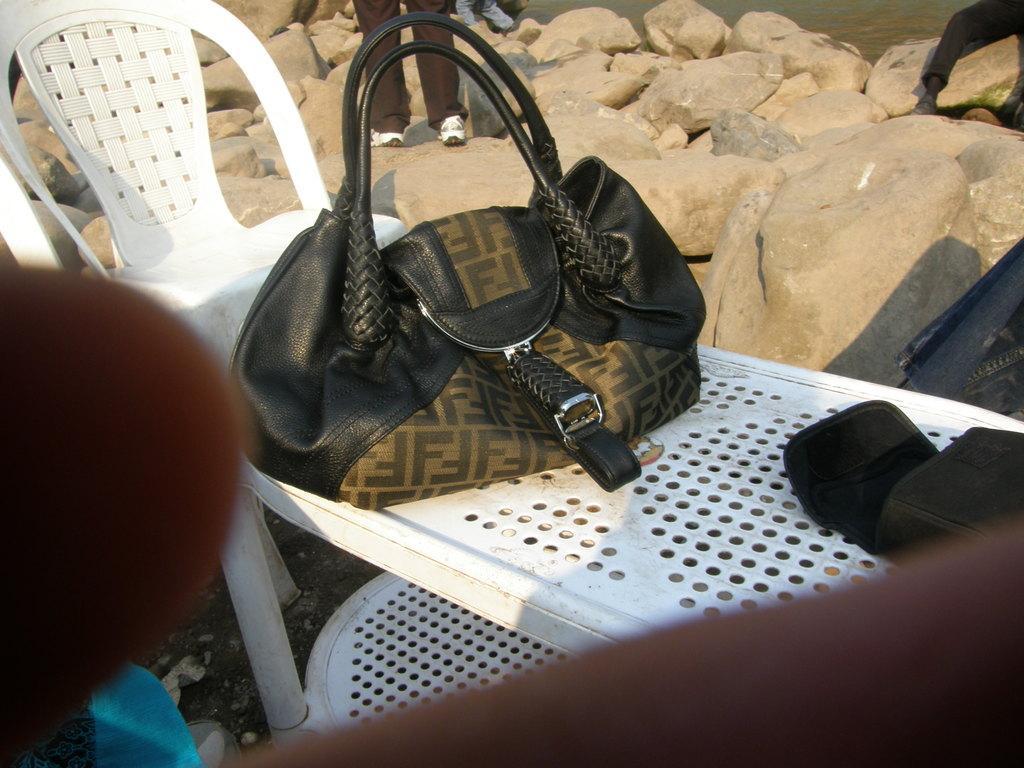Describe this image in one or two sentences. This image consist of a table on which bag is kept. To the left, there is a chair. In the background, there are rocks. In the middle, there is a man standing. 